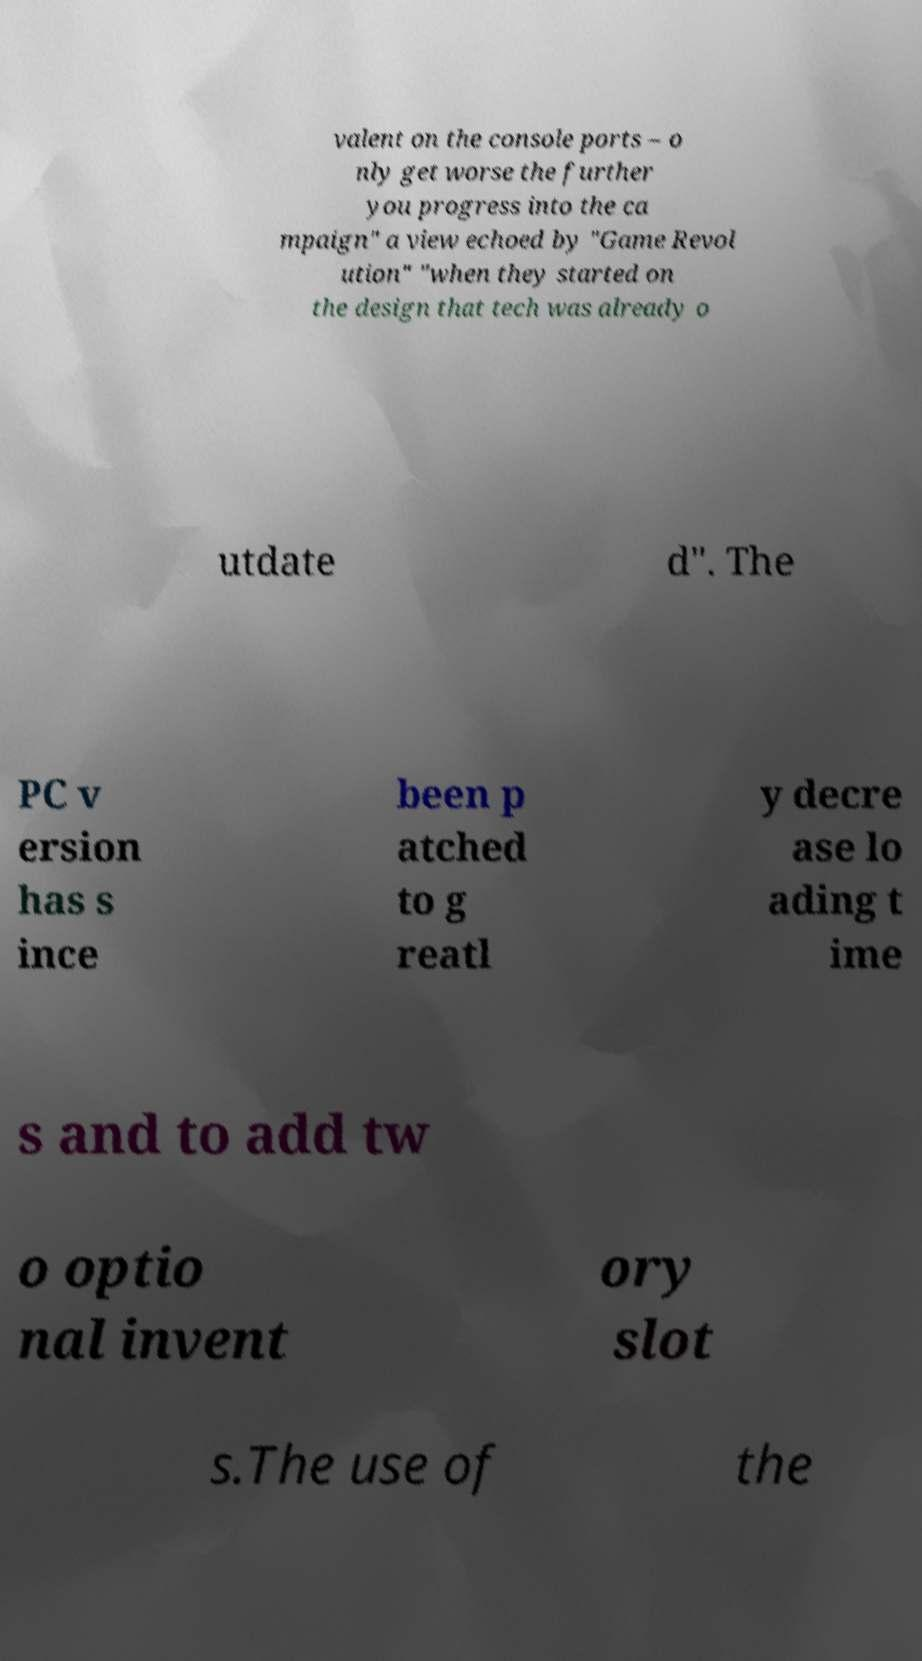Please identify and transcribe the text found in this image. valent on the console ports – o nly get worse the further you progress into the ca mpaign" a view echoed by "Game Revol ution" "when they started on the design that tech was already o utdate d". The PC v ersion has s ince been p atched to g reatl y decre ase lo ading t ime s and to add tw o optio nal invent ory slot s.The use of the 